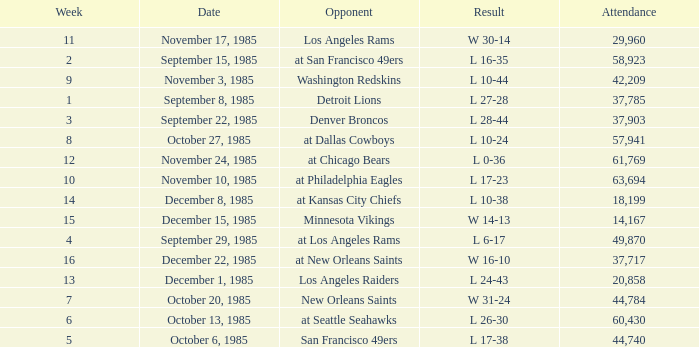Who was the opponent the falcons played against on week 3? Denver Broncos. 